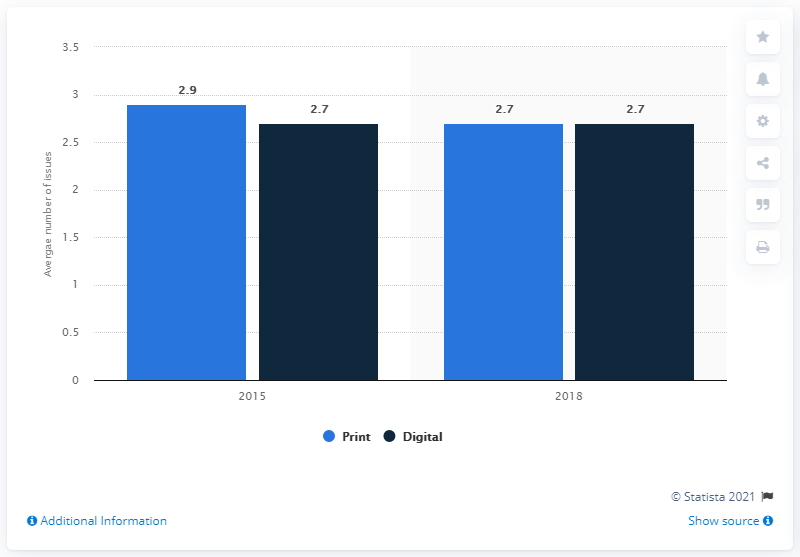Outline some significant characteristics in this image. In the United States in 2018, the average number of print magazines read was 2.7. 